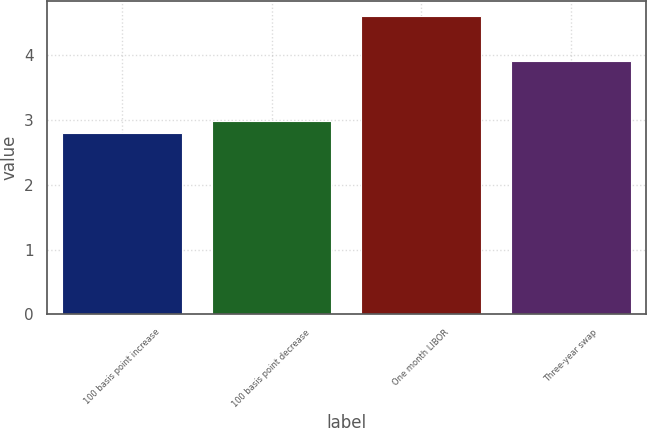Convert chart to OTSL. <chart><loc_0><loc_0><loc_500><loc_500><bar_chart><fcel>100 basis point increase<fcel>100 basis point decrease<fcel>One month LIBOR<fcel>Three-year swap<nl><fcel>2.8<fcel>2.98<fcel>4.6<fcel>3.91<nl></chart> 